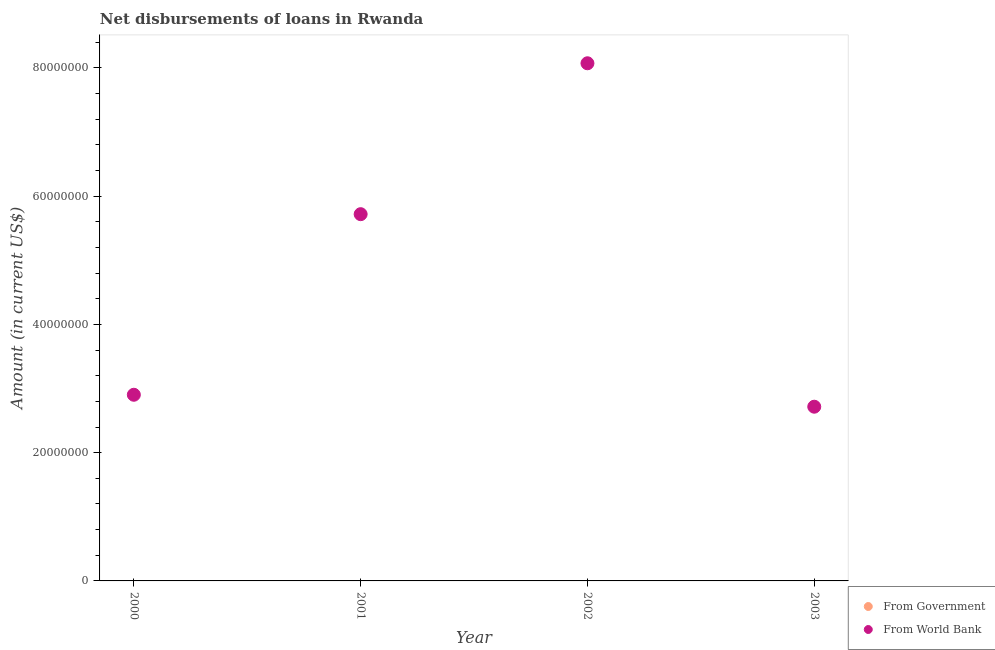Is the number of dotlines equal to the number of legend labels?
Keep it short and to the point. No. Across all years, what is the maximum net disbursements of loan from world bank?
Your answer should be very brief. 8.07e+07. In which year was the net disbursements of loan from world bank maximum?
Ensure brevity in your answer.  2002. What is the total net disbursements of loan from government in the graph?
Your answer should be very brief. 0. What is the difference between the net disbursements of loan from world bank in 2000 and that in 2003?
Provide a short and direct response. 1.86e+06. What is the difference between the net disbursements of loan from world bank in 2003 and the net disbursements of loan from government in 2002?
Offer a very short reply. 2.72e+07. What is the average net disbursements of loan from world bank per year?
Ensure brevity in your answer.  4.85e+07. What is the ratio of the net disbursements of loan from world bank in 2001 to that in 2003?
Give a very brief answer. 2.11. Is the net disbursements of loan from world bank in 2000 less than that in 2001?
Your answer should be very brief. Yes. What is the difference between the highest and the second highest net disbursements of loan from world bank?
Offer a terse response. 2.35e+07. What is the difference between the highest and the lowest net disbursements of loan from world bank?
Provide a succinct answer. 5.36e+07. Is the sum of the net disbursements of loan from world bank in 2001 and 2003 greater than the maximum net disbursements of loan from government across all years?
Your answer should be compact. Yes. Does the net disbursements of loan from world bank monotonically increase over the years?
Your answer should be very brief. No. Is the net disbursements of loan from world bank strictly less than the net disbursements of loan from government over the years?
Your answer should be very brief. No. Are the values on the major ticks of Y-axis written in scientific E-notation?
Your answer should be very brief. No. Does the graph contain any zero values?
Provide a succinct answer. Yes. Does the graph contain grids?
Give a very brief answer. No. Where does the legend appear in the graph?
Offer a terse response. Bottom right. How many legend labels are there?
Provide a succinct answer. 2. What is the title of the graph?
Provide a succinct answer. Net disbursements of loans in Rwanda. Does "Nitrous oxide emissions" appear as one of the legend labels in the graph?
Provide a succinct answer. No. What is the label or title of the Y-axis?
Provide a succinct answer. Amount (in current US$). What is the Amount (in current US$) in From Government in 2000?
Your answer should be compact. 0. What is the Amount (in current US$) of From World Bank in 2000?
Your answer should be very brief. 2.90e+07. What is the Amount (in current US$) in From Government in 2001?
Give a very brief answer. 0. What is the Amount (in current US$) in From World Bank in 2001?
Keep it short and to the point. 5.72e+07. What is the Amount (in current US$) of From Government in 2002?
Make the answer very short. 0. What is the Amount (in current US$) of From World Bank in 2002?
Provide a succinct answer. 8.07e+07. What is the Amount (in current US$) in From World Bank in 2003?
Offer a very short reply. 2.72e+07. Across all years, what is the maximum Amount (in current US$) in From World Bank?
Provide a succinct answer. 8.07e+07. Across all years, what is the minimum Amount (in current US$) of From World Bank?
Your answer should be compact. 2.72e+07. What is the total Amount (in current US$) of From Government in the graph?
Offer a terse response. 0. What is the total Amount (in current US$) of From World Bank in the graph?
Make the answer very short. 1.94e+08. What is the difference between the Amount (in current US$) of From World Bank in 2000 and that in 2001?
Your response must be concise. -2.82e+07. What is the difference between the Amount (in current US$) of From World Bank in 2000 and that in 2002?
Keep it short and to the point. -5.17e+07. What is the difference between the Amount (in current US$) in From World Bank in 2000 and that in 2003?
Provide a succinct answer. 1.86e+06. What is the difference between the Amount (in current US$) of From World Bank in 2001 and that in 2002?
Provide a succinct answer. -2.35e+07. What is the difference between the Amount (in current US$) in From World Bank in 2001 and that in 2003?
Your answer should be compact. 3.00e+07. What is the difference between the Amount (in current US$) in From World Bank in 2002 and that in 2003?
Your response must be concise. 5.36e+07. What is the average Amount (in current US$) in From World Bank per year?
Your response must be concise. 4.85e+07. What is the ratio of the Amount (in current US$) of From World Bank in 2000 to that in 2001?
Your response must be concise. 0.51. What is the ratio of the Amount (in current US$) in From World Bank in 2000 to that in 2002?
Your answer should be compact. 0.36. What is the ratio of the Amount (in current US$) in From World Bank in 2000 to that in 2003?
Your answer should be compact. 1.07. What is the ratio of the Amount (in current US$) of From World Bank in 2001 to that in 2002?
Offer a very short reply. 0.71. What is the ratio of the Amount (in current US$) of From World Bank in 2001 to that in 2003?
Your response must be concise. 2.11. What is the ratio of the Amount (in current US$) of From World Bank in 2002 to that in 2003?
Keep it short and to the point. 2.97. What is the difference between the highest and the second highest Amount (in current US$) in From World Bank?
Your answer should be compact. 2.35e+07. What is the difference between the highest and the lowest Amount (in current US$) in From World Bank?
Your answer should be compact. 5.36e+07. 